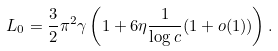Convert formula to latex. <formula><loc_0><loc_0><loc_500><loc_500>L _ { 0 } = \frac { 3 } { 2 } \pi ^ { 2 } \gamma \left ( 1 + 6 \eta \frac { 1 } { \log c } ( 1 + o ( 1 ) ) \right ) .</formula> 